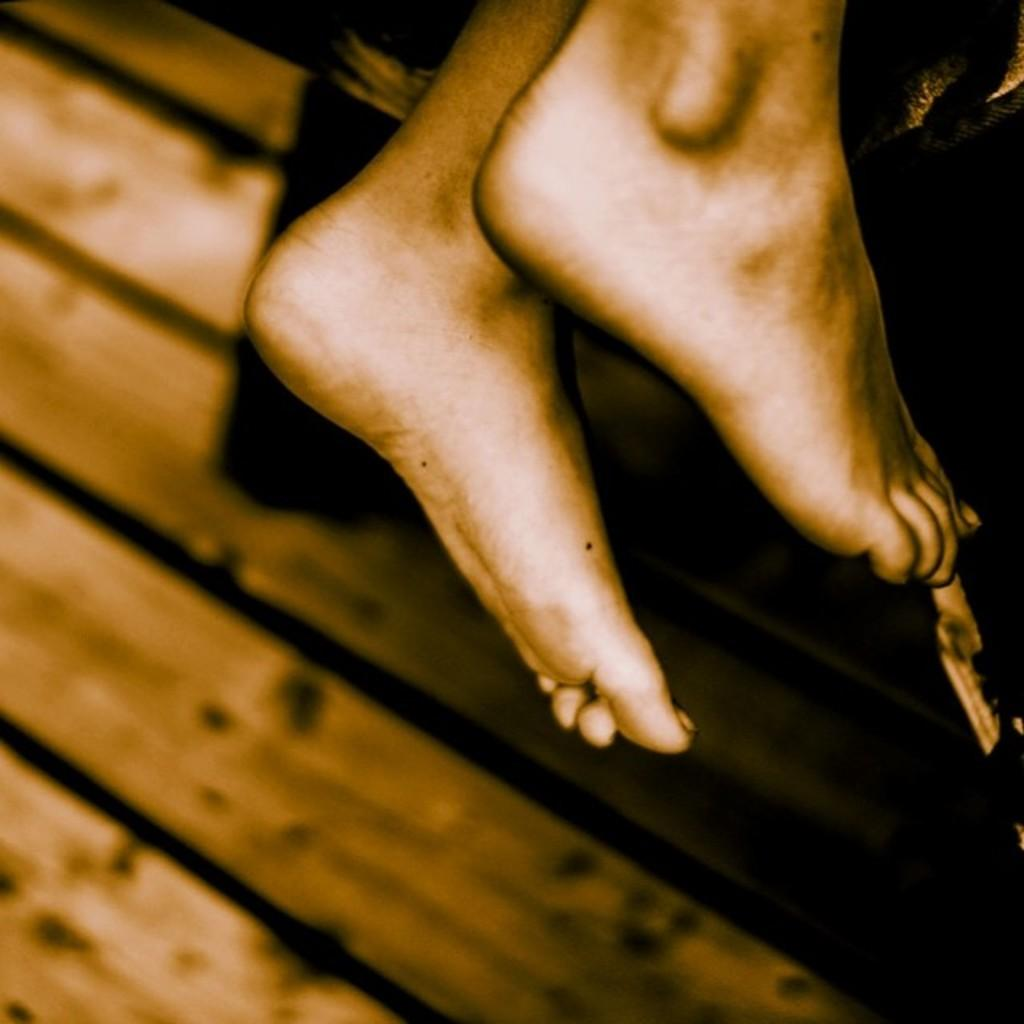What part of a person can be seen in the image? There are legs of a person visible in the image. What material is present in the image? There is wood present in the image. What type of root can be seen growing from the wood in the image? There is no root visible in the image; it only features legs of a person and wood. What type of musical instrument is being played in the image? There is no musical instrument, such as a guitar, present in the image. 